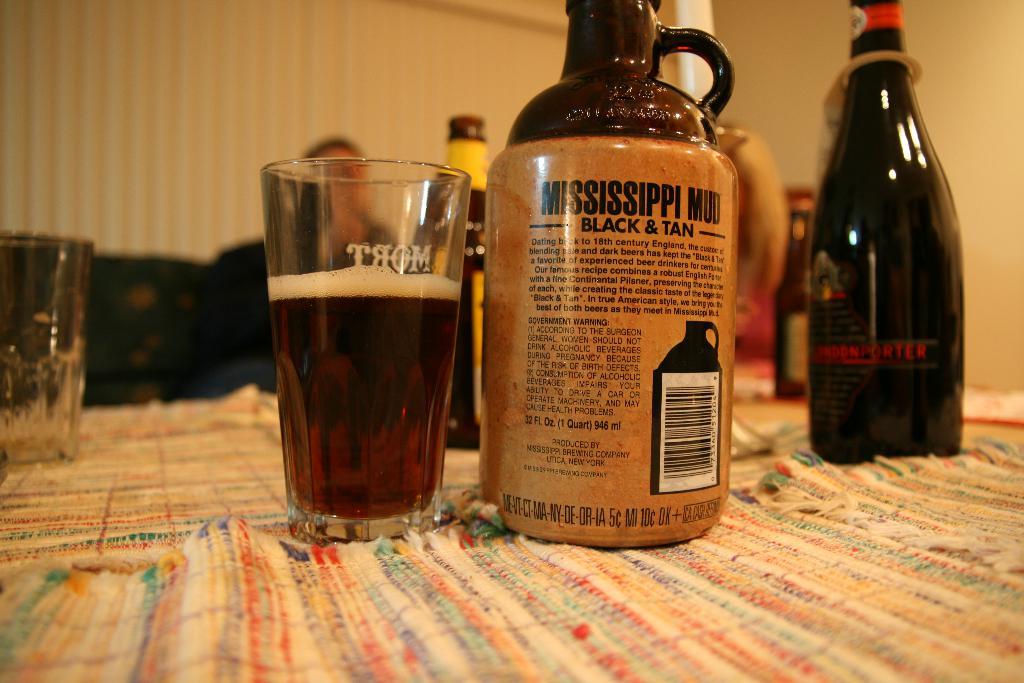What state is mentioned in the brand name of the alcohol?
Ensure brevity in your answer.  Mississippi. What name is on the drinking glass?
Your answer should be very brief. Mort. 